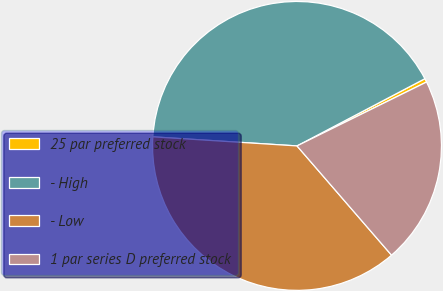Convert chart to OTSL. <chart><loc_0><loc_0><loc_500><loc_500><pie_chart><fcel>25 par preferred stock<fcel>- High<fcel>- Low<fcel>1 par series D preferred stock<nl><fcel>0.41%<fcel>41.29%<fcel>37.35%<fcel>20.94%<nl></chart> 